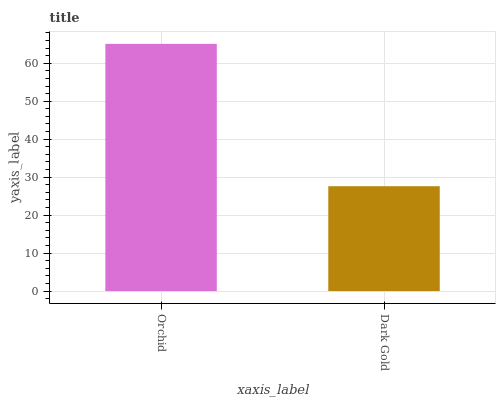Is Dark Gold the minimum?
Answer yes or no. Yes. Is Orchid the maximum?
Answer yes or no. Yes. Is Dark Gold the maximum?
Answer yes or no. No. Is Orchid greater than Dark Gold?
Answer yes or no. Yes. Is Dark Gold less than Orchid?
Answer yes or no. Yes. Is Dark Gold greater than Orchid?
Answer yes or no. No. Is Orchid less than Dark Gold?
Answer yes or no. No. Is Orchid the high median?
Answer yes or no. Yes. Is Dark Gold the low median?
Answer yes or no. Yes. Is Dark Gold the high median?
Answer yes or no. No. Is Orchid the low median?
Answer yes or no. No. 